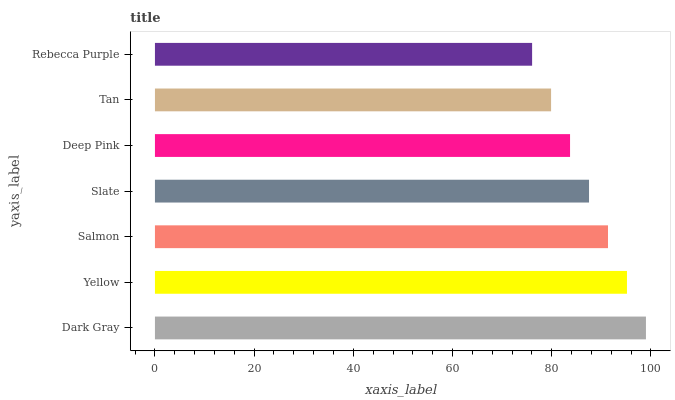Is Rebecca Purple the minimum?
Answer yes or no. Yes. Is Dark Gray the maximum?
Answer yes or no. Yes. Is Yellow the minimum?
Answer yes or no. No. Is Yellow the maximum?
Answer yes or no. No. Is Dark Gray greater than Yellow?
Answer yes or no. Yes. Is Yellow less than Dark Gray?
Answer yes or no. Yes. Is Yellow greater than Dark Gray?
Answer yes or no. No. Is Dark Gray less than Yellow?
Answer yes or no. No. Is Slate the high median?
Answer yes or no. Yes. Is Slate the low median?
Answer yes or no. Yes. Is Yellow the high median?
Answer yes or no. No. Is Dark Gray the low median?
Answer yes or no. No. 